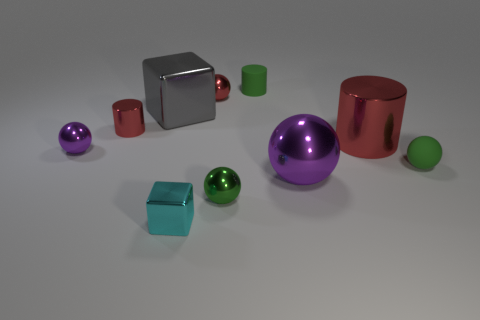What textures are visible in the image? The image showcases a variety of textures. The surfaces of the cubes and spheres are smooth and reflective, indicative of a metallic texture. The green cylinder and the small green sphere have a matte finish, which is non-reflective and suggests a more diffuse surface texture. 